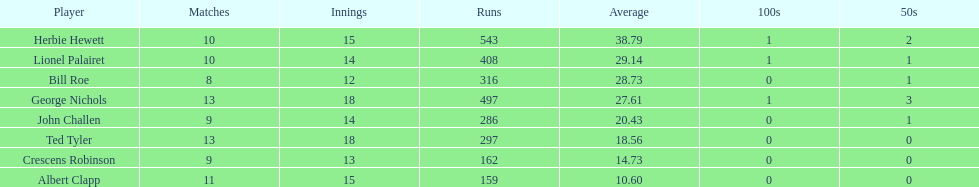How many runs did ted tyler have? 297. 